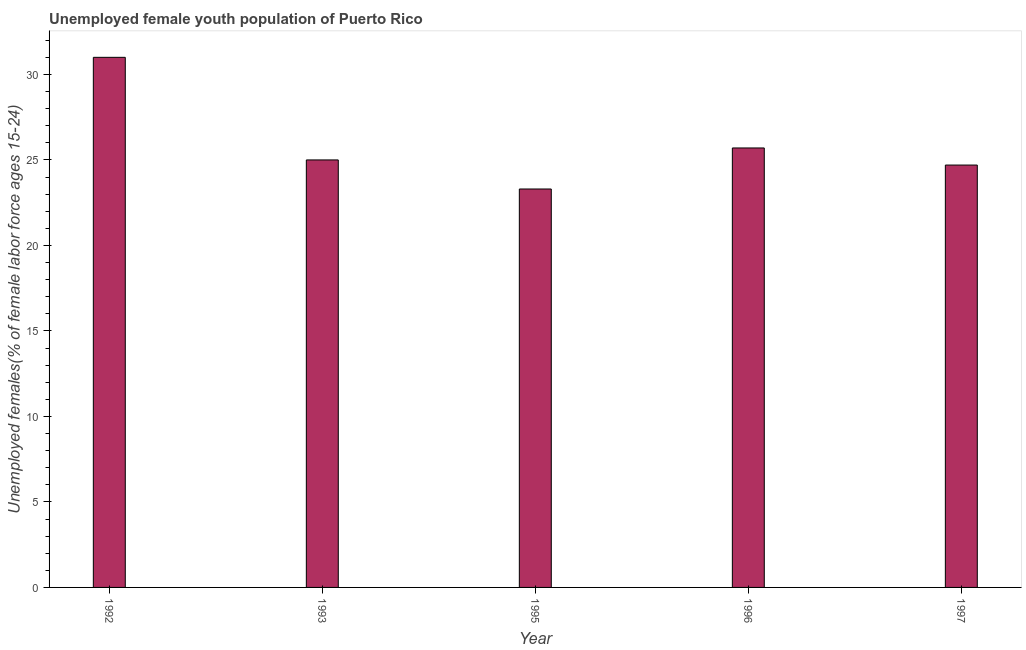Does the graph contain any zero values?
Offer a very short reply. No. What is the title of the graph?
Ensure brevity in your answer.  Unemployed female youth population of Puerto Rico. What is the label or title of the Y-axis?
Keep it short and to the point. Unemployed females(% of female labor force ages 15-24). Across all years, what is the maximum unemployed female youth?
Provide a short and direct response. 31. Across all years, what is the minimum unemployed female youth?
Ensure brevity in your answer.  23.3. In which year was the unemployed female youth maximum?
Give a very brief answer. 1992. In which year was the unemployed female youth minimum?
Provide a succinct answer. 1995. What is the sum of the unemployed female youth?
Your answer should be very brief. 129.7. What is the average unemployed female youth per year?
Provide a short and direct response. 25.94. Do a majority of the years between 1992 and 1996 (inclusive) have unemployed female youth greater than 21 %?
Your answer should be compact. Yes. What is the ratio of the unemployed female youth in 1992 to that in 1996?
Make the answer very short. 1.21. Is the unemployed female youth in 1993 less than that in 1997?
Offer a terse response. No. Is the difference between the unemployed female youth in 1995 and 1996 greater than the difference between any two years?
Provide a succinct answer. No. What is the difference between the highest and the lowest unemployed female youth?
Your answer should be compact. 7.7. In how many years, is the unemployed female youth greater than the average unemployed female youth taken over all years?
Provide a succinct answer. 1. How many years are there in the graph?
Your response must be concise. 5. What is the Unemployed females(% of female labor force ages 15-24) of 1993?
Your answer should be compact. 25. What is the Unemployed females(% of female labor force ages 15-24) of 1995?
Ensure brevity in your answer.  23.3. What is the Unemployed females(% of female labor force ages 15-24) in 1996?
Provide a short and direct response. 25.7. What is the Unemployed females(% of female labor force ages 15-24) of 1997?
Offer a terse response. 24.7. What is the difference between the Unemployed females(% of female labor force ages 15-24) in 1992 and 1995?
Your response must be concise. 7.7. What is the difference between the Unemployed females(% of female labor force ages 15-24) in 1992 and 1996?
Your answer should be compact. 5.3. What is the difference between the Unemployed females(% of female labor force ages 15-24) in 1992 and 1997?
Make the answer very short. 6.3. What is the difference between the Unemployed females(% of female labor force ages 15-24) in 1993 and 1996?
Offer a terse response. -0.7. What is the difference between the Unemployed females(% of female labor force ages 15-24) in 1993 and 1997?
Provide a short and direct response. 0.3. What is the difference between the Unemployed females(% of female labor force ages 15-24) in 1995 and 1997?
Your response must be concise. -1.4. What is the difference between the Unemployed females(% of female labor force ages 15-24) in 1996 and 1997?
Ensure brevity in your answer.  1. What is the ratio of the Unemployed females(% of female labor force ages 15-24) in 1992 to that in 1993?
Give a very brief answer. 1.24. What is the ratio of the Unemployed females(% of female labor force ages 15-24) in 1992 to that in 1995?
Make the answer very short. 1.33. What is the ratio of the Unemployed females(% of female labor force ages 15-24) in 1992 to that in 1996?
Provide a short and direct response. 1.21. What is the ratio of the Unemployed females(% of female labor force ages 15-24) in 1992 to that in 1997?
Provide a succinct answer. 1.25. What is the ratio of the Unemployed females(% of female labor force ages 15-24) in 1993 to that in 1995?
Ensure brevity in your answer.  1.07. What is the ratio of the Unemployed females(% of female labor force ages 15-24) in 1995 to that in 1996?
Keep it short and to the point. 0.91. What is the ratio of the Unemployed females(% of female labor force ages 15-24) in 1995 to that in 1997?
Your response must be concise. 0.94. What is the ratio of the Unemployed females(% of female labor force ages 15-24) in 1996 to that in 1997?
Keep it short and to the point. 1.04. 